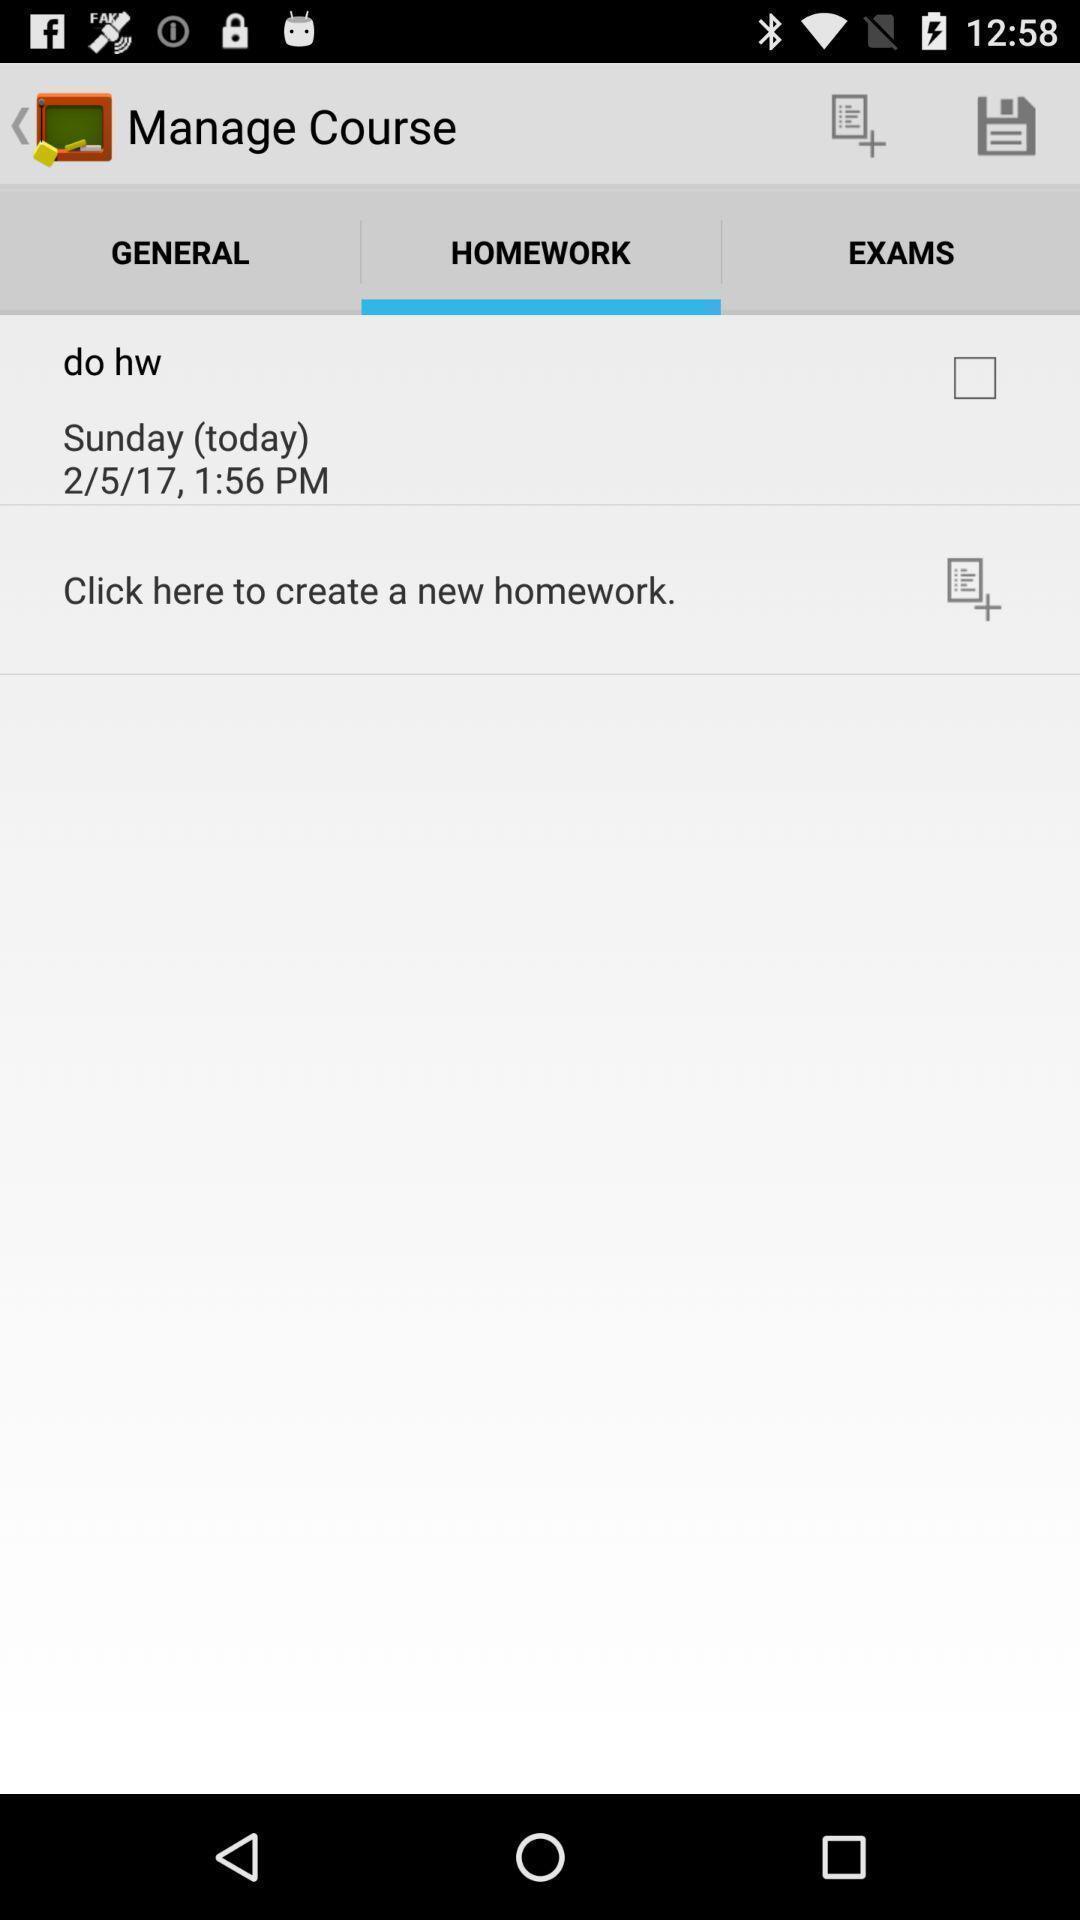Describe the content in this image. Screen shows homework details in a learning app. 